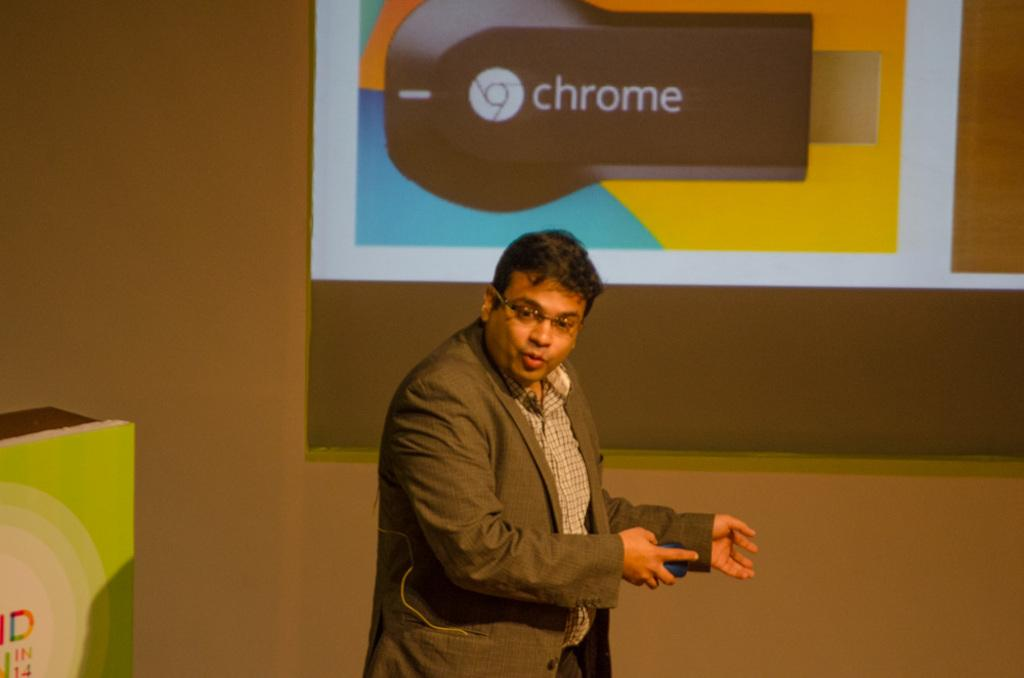What is the main subject of the image? There is a man standing in the image. What is the man wearing? The man is wearing a blazer. Where is the man located in the image? The man is at the bottom of the image. What can be seen in the background of the image? There is a wall in the background of the image. What is at the top of the image? There is a screen at the top of the image. How many feet of paper can be seen in the image? There is no paper visible in the image. What is the man's way of communicating with the screen at the top of the image? The image does not provide information about how the man is communicating with the screen, if at all. 